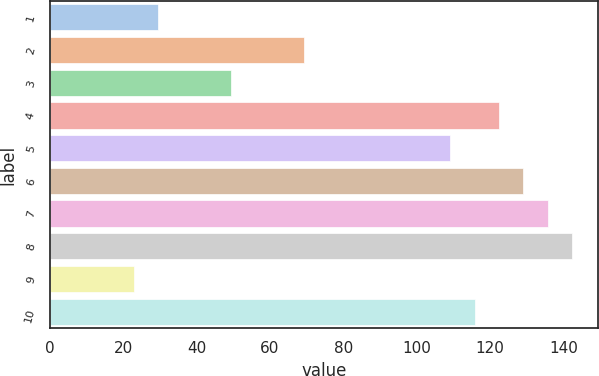Convert chart. <chart><loc_0><loc_0><loc_500><loc_500><bar_chart><fcel>1<fcel>2<fcel>3<fcel>4<fcel>5<fcel>6<fcel>7<fcel>8<fcel>9<fcel>10<nl><fcel>29.61<fcel>69.39<fcel>49.5<fcel>122.43<fcel>109.17<fcel>129.06<fcel>135.69<fcel>142.32<fcel>22.98<fcel>115.8<nl></chart> 